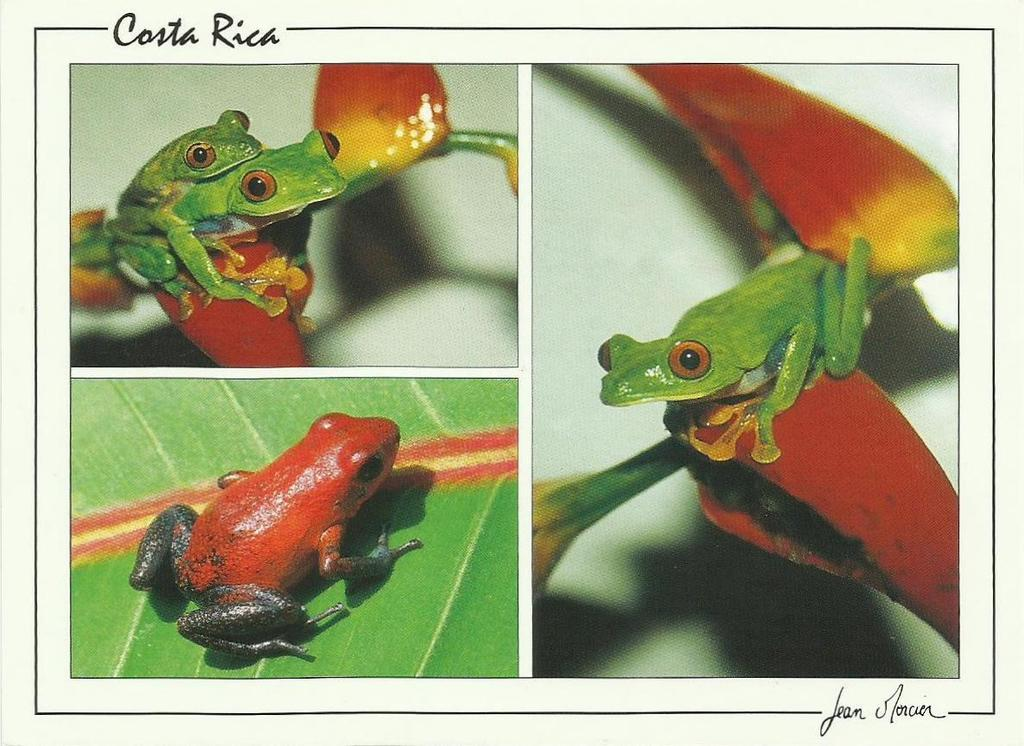What type of artwork is depicted in the image? The image is a collage. What animals are featured in the collage? There are frogs in the image. Can you describe a specific frog in the collage? There is a red frog in the image. Where is the red frog located in the collage? The red frog is on a leaf. What type of oatmeal is being served on the street in the image? There is no oatmeal or street present in the image; it is a collage featuring frogs. What is the title of the collage in the image? The image does not have a title, as it is a description of the visual content. 